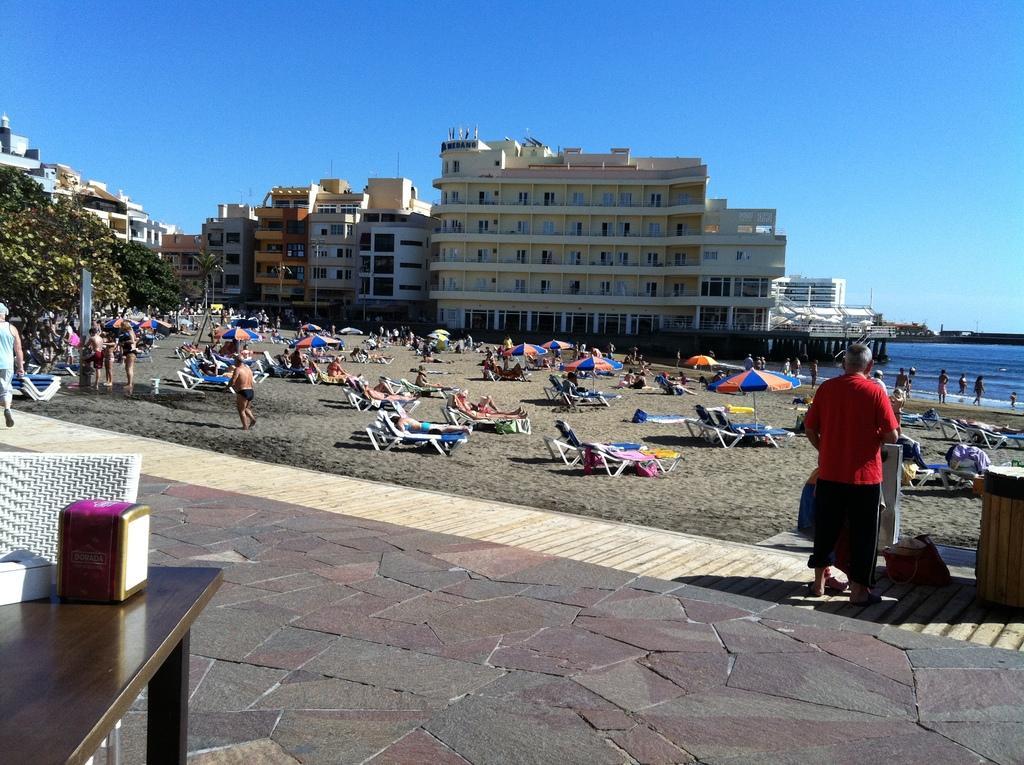Could you give a brief overview of what you see in this image? In this image I can see there are crowd of people visible in the middle and some beds and tents, trees , building and the sea visible in the middle at the top I can see the sky , on the table I can see object and I can see white color chair in front of table and I can see a person ,wearing a red color t-shirt standing on floor and I can see a wooden stand on the right side. 